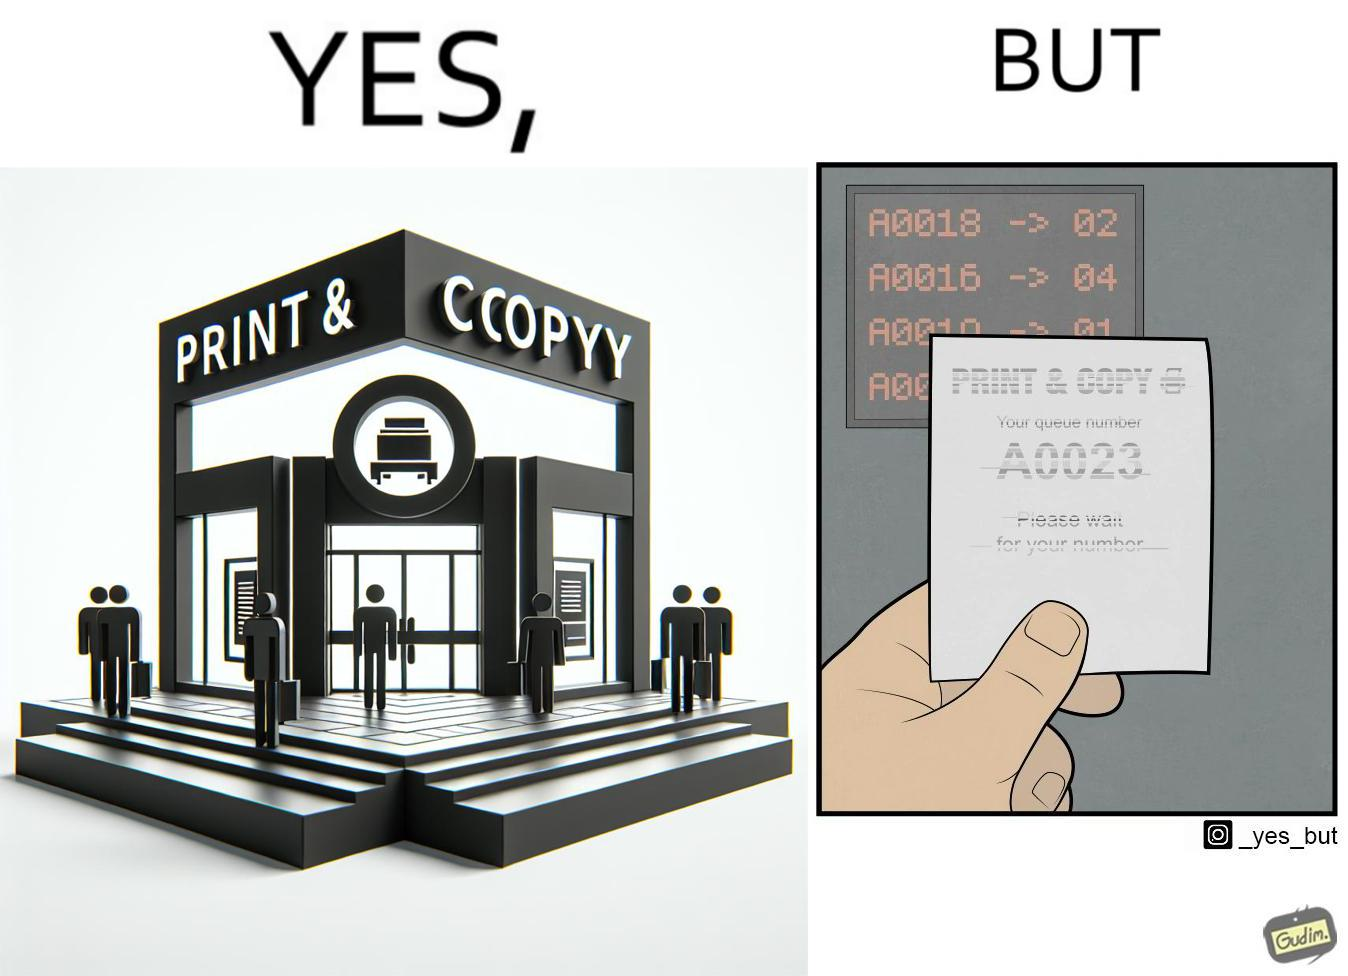What is shown in this image? The image is ironic, as the waiting slip in a "Print & Copy" Centre is printed with insufficient printing ink. 